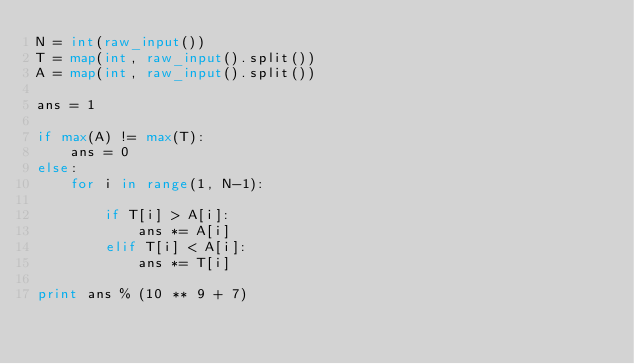Convert code to text. <code><loc_0><loc_0><loc_500><loc_500><_Python_>N = int(raw_input())
T = map(int, raw_input().split())
A = map(int, raw_input().split())

ans = 1

if max(A) != max(T):
    ans = 0
else:
    for i in range(1, N-1):

        if T[i] > A[i]:
            ans *= A[i]
        elif T[i] < A[i]:
            ans *= T[i]

print ans % (10 ** 9 + 7)</code> 